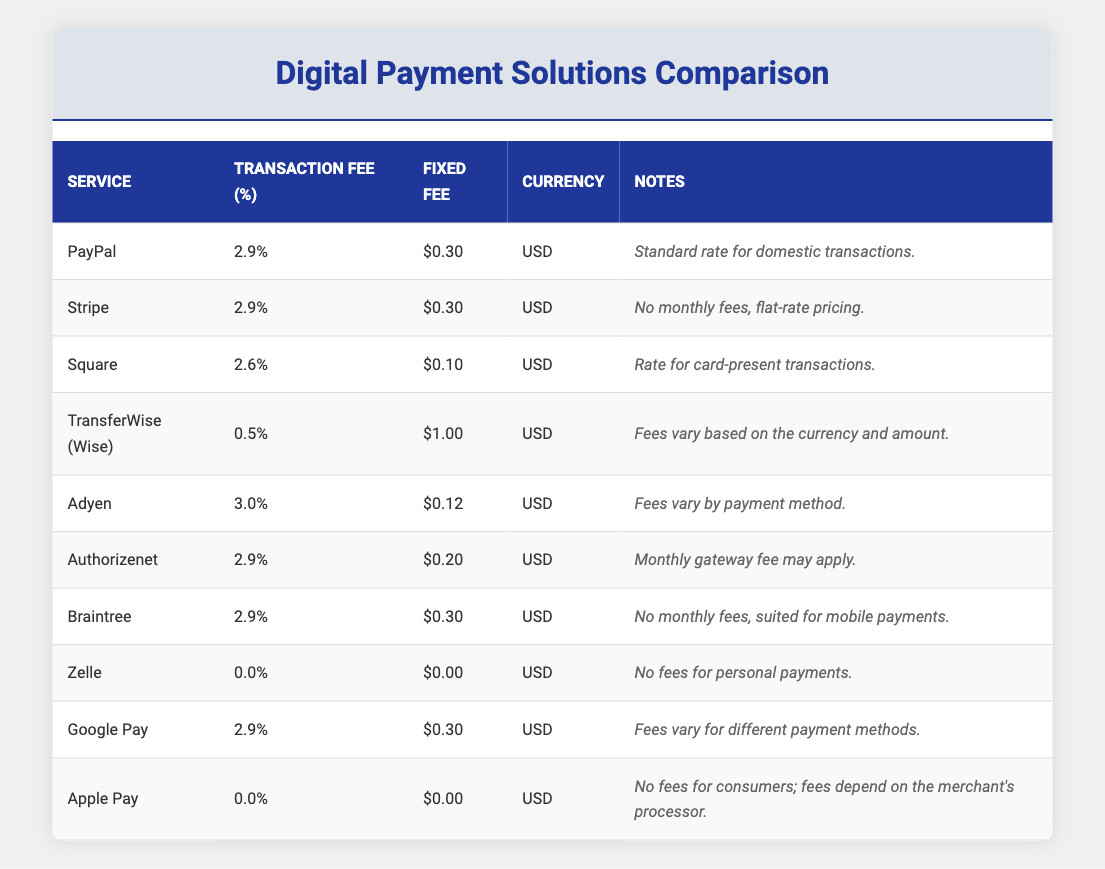What is the fixed transaction fee for PayPal? The fixed transaction fee for PayPal is listed directly in the table under the "Fixed Fee" column. According to the table, it is 0.30 USD.
Answer: 0.30 USD Which digital payment service has the lowest transaction fee percentage? By scanning the "Transaction Fee (%)" column, TransferWise (Wise) shows a transaction fee percentage of 0.5, which is the lowest among all the services listed.
Answer: 0.5 Is there any digital payment service with no transaction fees? Upon examining the "Transaction Fee (%)" column, Zelle and Apple Pay both have a transaction fee of 0.0, indicating no fees for their services. Therefore, the answer is yes.
Answer: Yes What is the average transaction fee percentage of the payment services listed? To find the average, sum up the transaction fees (2.9 + 2.9 + 2.6 + 0.5 + 3.0 + 2.9 + 2.9 + 0.0 + 2.9 + 0.0 = 22.6) and divide by the number of services (10). Thus, the average transaction fee percentage is 22.6 / 10 = 2.26.
Answer: 2.26 Is the fixed transaction fee for Square less than that of Adyen? The fixed transaction fee for Square is 0.10, and for Adyen, it is 0.12. Since 0.10 is less than 0.12, this statement is true.
Answer: Yes How many services have a transaction fee percentage of 2.9? The table shows that PayPal, Stripe, Authorizenet, and Braintree each have a transaction fee percentage of 2.9, making a total of 4 services with this fee.
Answer: 4 Which service has the highest fixed transaction fee, and what is it? Comparing the "Fixed Fee" column, TransferWise (Wise) has the highest fixed fee of 1.00 USD, as it is higher than any other fixed fees listed in the table.
Answer: TransferWise (Wise), 1.00 USD What is the difference between the highest and lowest transaction fee percentages? Adyen has the highest transaction fee at 3.0 and Zelle has the lowest at 0.0. The difference is calculated as 3.0 - 0.0 = 3.0.
Answer: 3.0 